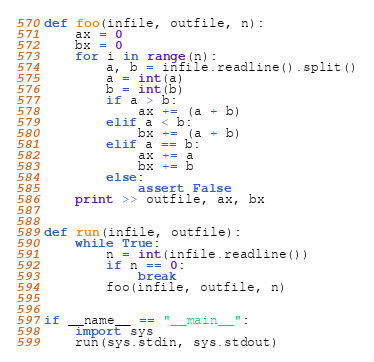<code> <loc_0><loc_0><loc_500><loc_500><_Python_>def foo(infile, outfile, n):
    ax = 0
    bx = 0
    for i in range(n):
        a, b = infile.readline().split()
        a = int(a)
        b = int(b)
        if a > b:
            ax += (a + b)
        elif a < b:
            bx += (a + b)
        elif a == b:
            ax += a
            bx += b
        else:
            assert False
    print >> outfile, ax, bx


def run(infile, outfile):
    while True:
        n = int(infile.readline())
        if n == 0:
            break
        foo(infile, outfile, n)


if __name__ == "__main__":
    import sys
    run(sys.stdin, sys.stdout)</code> 